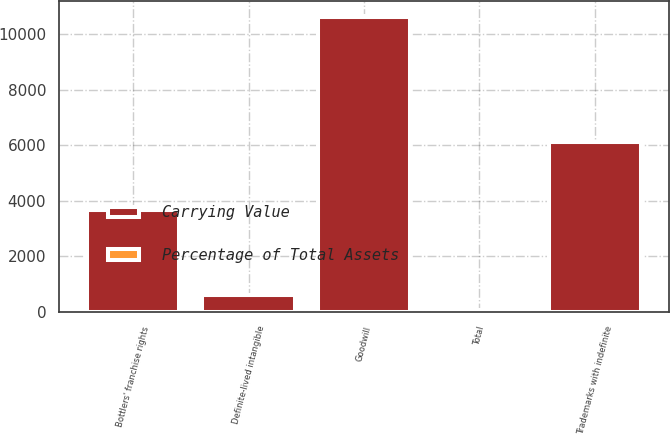Convert chart to OTSL. <chart><loc_0><loc_0><loc_500><loc_500><stacked_bar_chart><ecel><fcel>Goodwill<fcel>Trademarks with indefinite<fcel>Bottlers' franchise rights<fcel>Definite-lived intangible<fcel>Total<nl><fcel>Carrying Value<fcel>10629<fcel>6097<fcel>3676<fcel>598<fcel>24<nl><fcel>Percentage of Total Assets<fcel>12<fcel>7<fcel>4<fcel>1<fcel>24<nl></chart> 